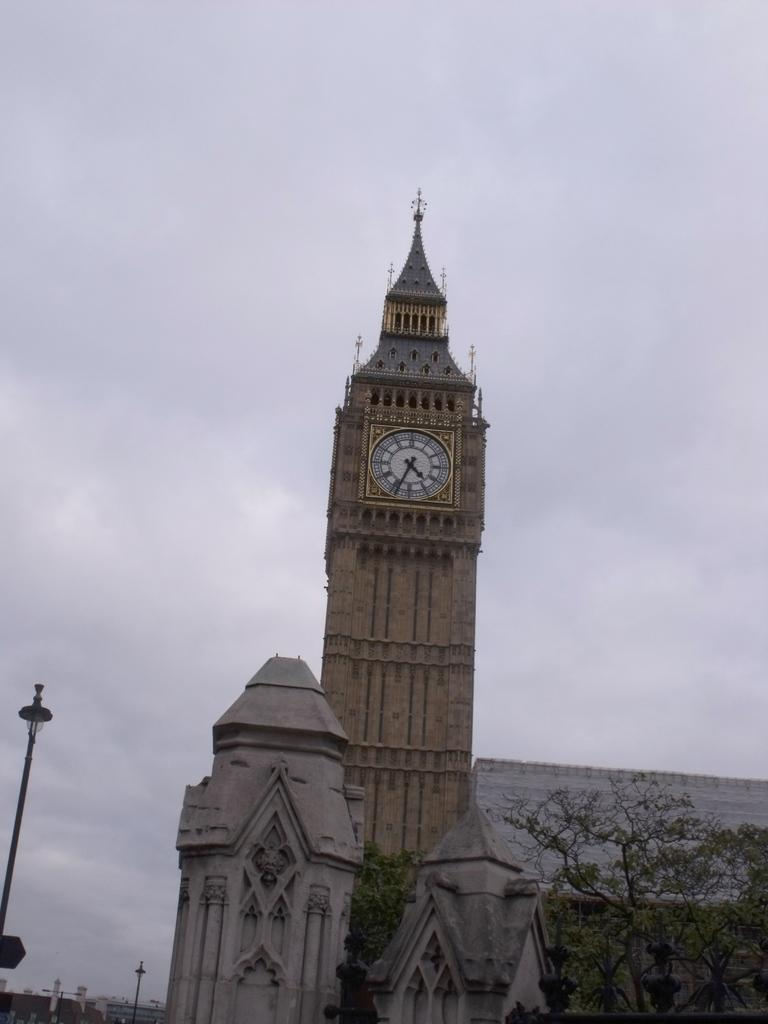What is the main structure in the foreground of the image? There is a clock tower in the foreground of the image. What other objects or structures are present in the foreground? There are buildings and trees in the foreground of the image. What else can be seen in the foreground? There is a pole in the foreground of the image. Can you describe the background of the image? There are poles, buildings, and clouds visible in the background of the image. What type of shoes can be seen hanging from the clock tower in the image? There are no shoes visible in the image, and they are not hanging from the clock tower. 